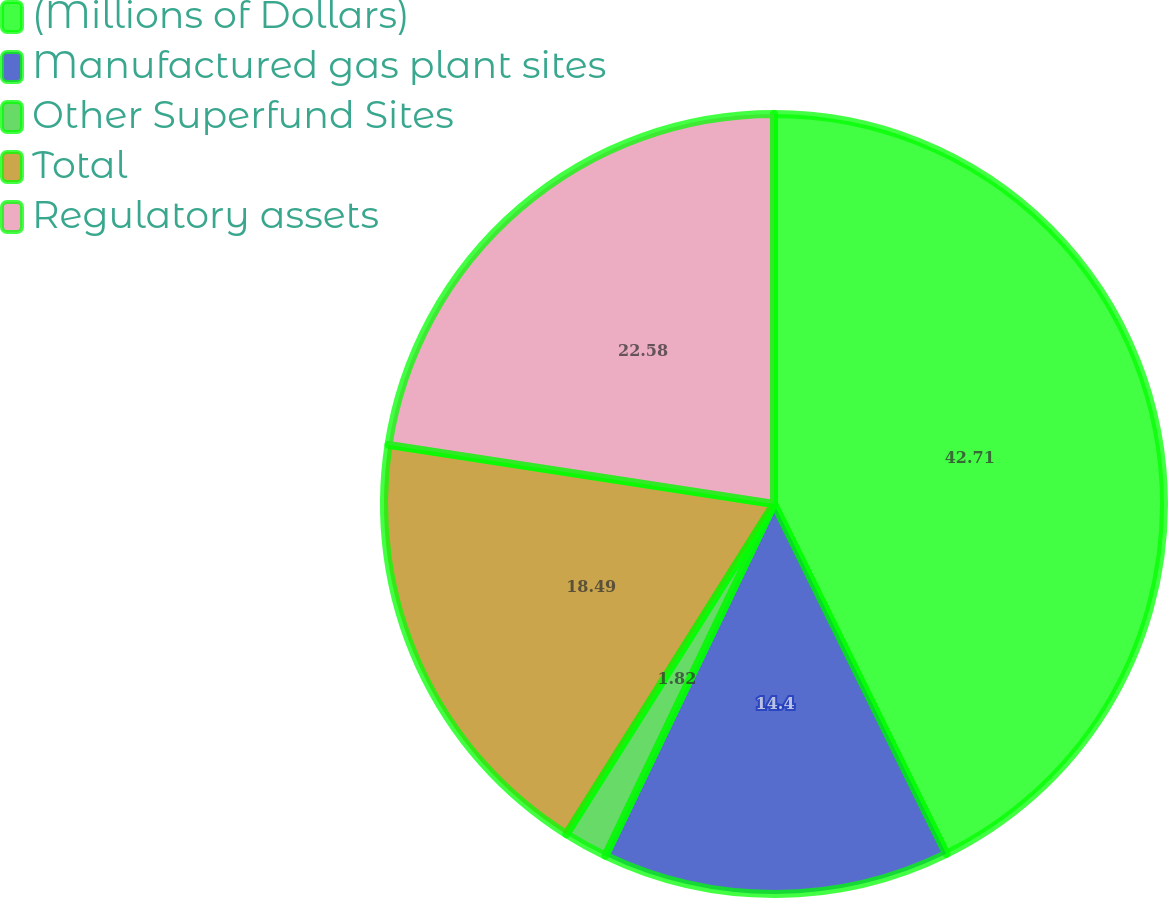<chart> <loc_0><loc_0><loc_500><loc_500><pie_chart><fcel>(Millions of Dollars)<fcel>Manufactured gas plant sites<fcel>Other Superfund Sites<fcel>Total<fcel>Regulatory assets<nl><fcel>42.72%<fcel>14.4%<fcel>1.82%<fcel>18.49%<fcel>22.58%<nl></chart> 